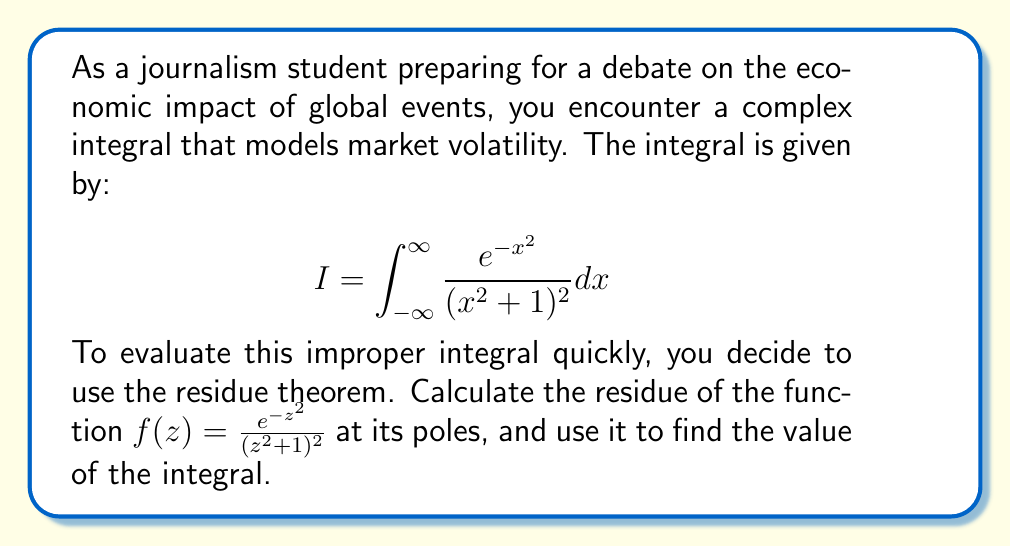Provide a solution to this math problem. 1) First, we identify the poles of $f(z)$. They occur when $z^2 + 1 = 0$, i.e., at $z = \pm i$.

2) These are second-order poles because $(z^2 + 1)^2$ is squared in the denominator.

3) To calculate the residue at $z = i$, we use the formula for the residue of a second-order pole:

   $$\text{Res}(f, i) = \lim_{z \to i} \frac{d}{dz} [(z-i)^2 f(z)]$$

4) Let's compute this:
   $$(z-i)^2 f(z) = (z-i)^2 \frac{e^{-z^2}}{(z^2 + 1)^2} = \frac{(z-i)^2 e^{-z^2}}{(z+i)^2(z-i)^2} = \frac{e^{-z^2}}{(z+i)^2}$$

5) Differentiating:
   $$\frac{d}{dz} \left[\frac{e^{-z^2}}{(z+i)^2}\right] = \frac{-2ze^{-z^2}(z+i)^2 - 2(z+i)e^{-z^2}}{(z+i)^4}$$

6) Now, we take the limit as $z \to i$:
   $$\text{Res}(f, i) = \lim_{z \to i} \frac{-2ze^{-z^2}(z+i)^2 - 2(z+i)e^{-z^2}}{(z+i)^4}$$
   $$= \frac{-2ie^{-i^2}(2i)^2 - 2(2i)e^{-i^2}}{(2i)^4} = \frac{8ie^{-i^2} - 4ie^{-i^2}}{16i^4} = \frac{e^{-i^2}}{4i^3}$$

7) The residue at $z = -i$ is the complex conjugate of this, so:
   $$\text{Res}(f, -i) = -\frac{e^{-(-i)^2}}{4(-i)^3} = -\frac{e^{-i^2}}{4i^3}$$

8) By the residue theorem, for a function with poles inside the upper half-plane:
   $$\int_{-\infty}^{\infty} f(x) dx = 2\pi i \sum \text{Res}(f, \text{poles in upper half-plane})$$

9) Therefore:
   $$I = 2\pi i \cdot \text{Res}(f, i) = 2\pi i \cdot \frac{e^{-i^2}}{4i^3} = \frac{\pi e^{-i^2}}{2i^2} = \frac{\pi e}{2}$$

   Note: $e^{-i^2} = e^1 = e$
Answer: $\frac{\pi e}{2}$ 